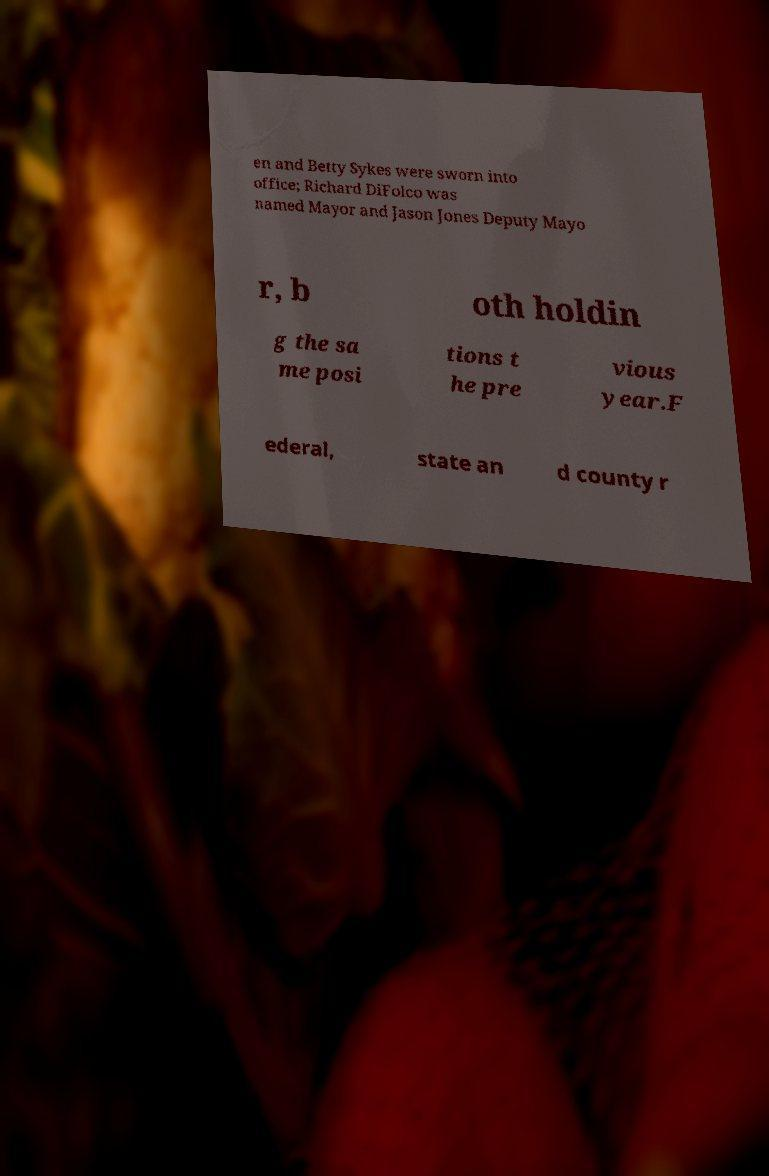Could you assist in decoding the text presented in this image and type it out clearly? en and Betty Sykes were sworn into office; Richard DiFolco was named Mayor and Jason Jones Deputy Mayo r, b oth holdin g the sa me posi tions t he pre vious year.F ederal, state an d county r 